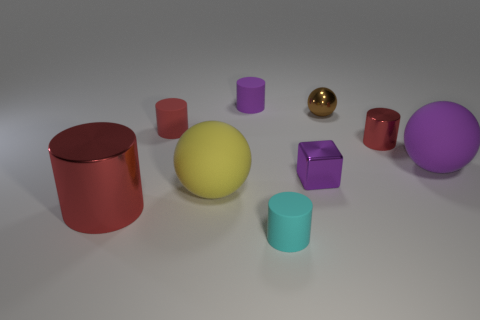Subtract all yellow blocks. How many red cylinders are left? 3 Subtract all purple cylinders. How many cylinders are left? 4 Subtract all small cyan cylinders. How many cylinders are left? 4 Subtract all purple cylinders. Subtract all yellow balls. How many cylinders are left? 4 Subtract all cubes. How many objects are left? 8 Add 4 big rubber things. How many big rubber things are left? 6 Add 6 cubes. How many cubes exist? 7 Subtract 1 cyan cylinders. How many objects are left? 8 Subtract all tiny gray balls. Subtract all small brown metallic objects. How many objects are left? 8 